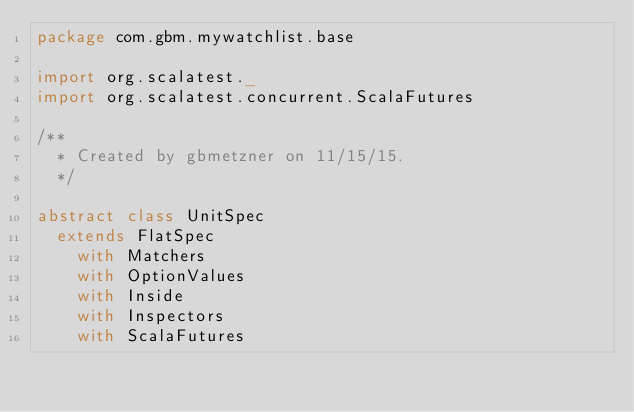<code> <loc_0><loc_0><loc_500><loc_500><_Scala_>package com.gbm.mywatchlist.base

import org.scalatest._
import org.scalatest.concurrent.ScalaFutures

/**
  * Created by gbmetzner on 11/15/15.
  */

abstract class UnitSpec
  extends FlatSpec
    with Matchers
    with OptionValues
    with Inside
    with Inspectors
    with ScalaFutures</code> 